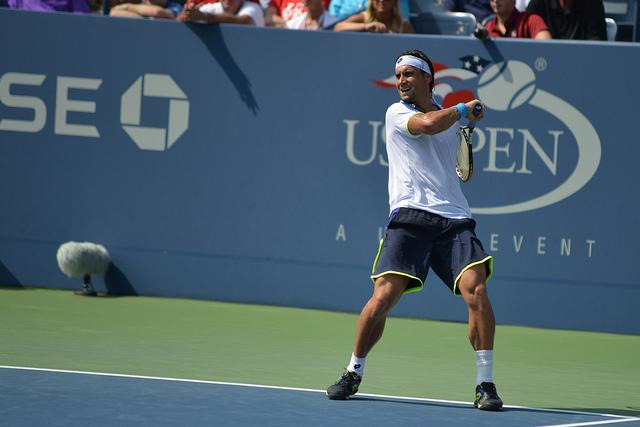Why does he have the racquet behind him?

Choices:
A) strike ball
B) bad arm
C) stole it
D) hiding it strike ball 